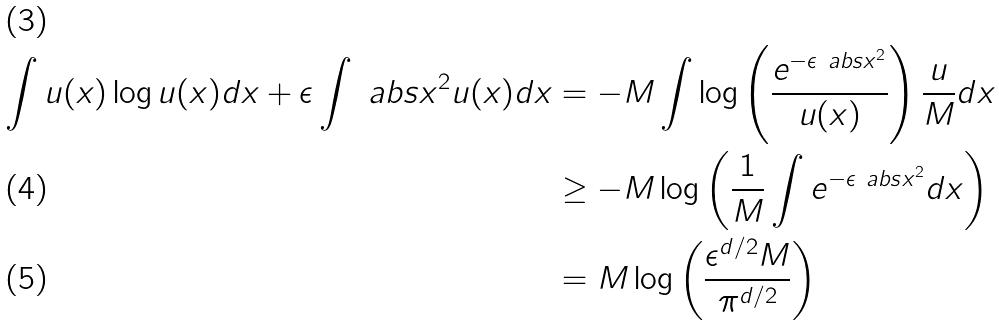<formula> <loc_0><loc_0><loc_500><loc_500>\int u ( x ) \log u ( x ) d x + \epsilon \int \ a b s { x } ^ { 2 } u ( x ) d x & = - M \int \log \left ( \frac { e ^ { - \epsilon \ a b s { x } ^ { 2 } } } { u ( x ) } \right ) \frac { u } { M } d x \\ & \geq - M \log \left ( \frac { 1 } { M } \int e ^ { - \epsilon \ a b s { x } ^ { 2 } } d x \right ) \\ & = M \log \left ( \frac { \epsilon ^ { d / 2 } M } { \pi ^ { d / 2 } } \right )</formula> 